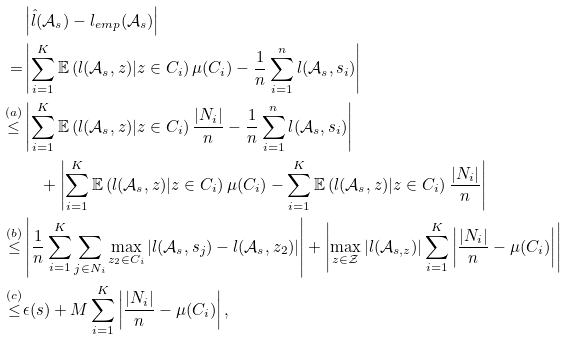Convert formula to latex. <formula><loc_0><loc_0><loc_500><loc_500>& \left | \hat { l } ( \mathcal { A } _ { s } ) - l _ { e m p } ( \mathcal { A } _ { s } ) \right | \\ = & \left | \sum _ { i = 1 } ^ { K } \mathbb { E } \left ( l ( \mathcal { A } _ { s } , z ) | z \in C _ { i } \right ) \mu ( C _ { i } ) - \frac { 1 } { n } \sum _ { i = 1 } ^ { n } l ( \mathcal { A } _ { s } , s _ { i } ) \right | \\ \stackrel { ( a ) } { \leq } & \left | \sum _ { i = 1 } ^ { K } \mathbb { E } \left ( l ( \mathcal { A } _ { s } , z ) | z \in C _ { i } \right ) \frac { | N _ { i } | } { n } - \frac { 1 } { n } \sum _ { i = 1 } ^ { n } l ( \mathcal { A } _ { s } , s _ { i } ) \right | \\ & \quad + \left | \sum _ { i = 1 } ^ { K } \mathbb { E } \left ( l ( \mathcal { A } _ { s } , z ) | z \in C _ { i } \right ) \mu ( C _ { i } ) - \sum _ { i = 1 } ^ { K } \mathbb { E } \left ( l ( \mathcal { A } _ { s } , z ) | z \in C _ { i } \right ) \frac { | N _ { i } | } { n } \right | \\ \stackrel { ( b ) } { \leq } & \left | \frac { 1 } { n } \sum _ { i = 1 } ^ { K } \sum _ { j \in N _ { i } } \max _ { z _ { 2 } \in C _ { i } } | l ( \mathcal { A } _ { s } , s _ { j } ) - l ( \mathcal { A } _ { s } , z _ { 2 } ) | \right | + \left | \max _ { z \in \mathcal { Z } } | l ( \mathcal { A } _ { s , z } ) | \sum _ { i = 1 } ^ { K } \left | \frac { | N _ { i } | } { n } - \mu ( C _ { i } ) \right | \right | \\ \stackrel { ( c ) } { \leq } & \epsilon ( s ) + M \sum _ { i = 1 } ^ { K } \left | \frac { | N _ { i } | } { n } - \mu ( C _ { i } ) \right | ,</formula> 